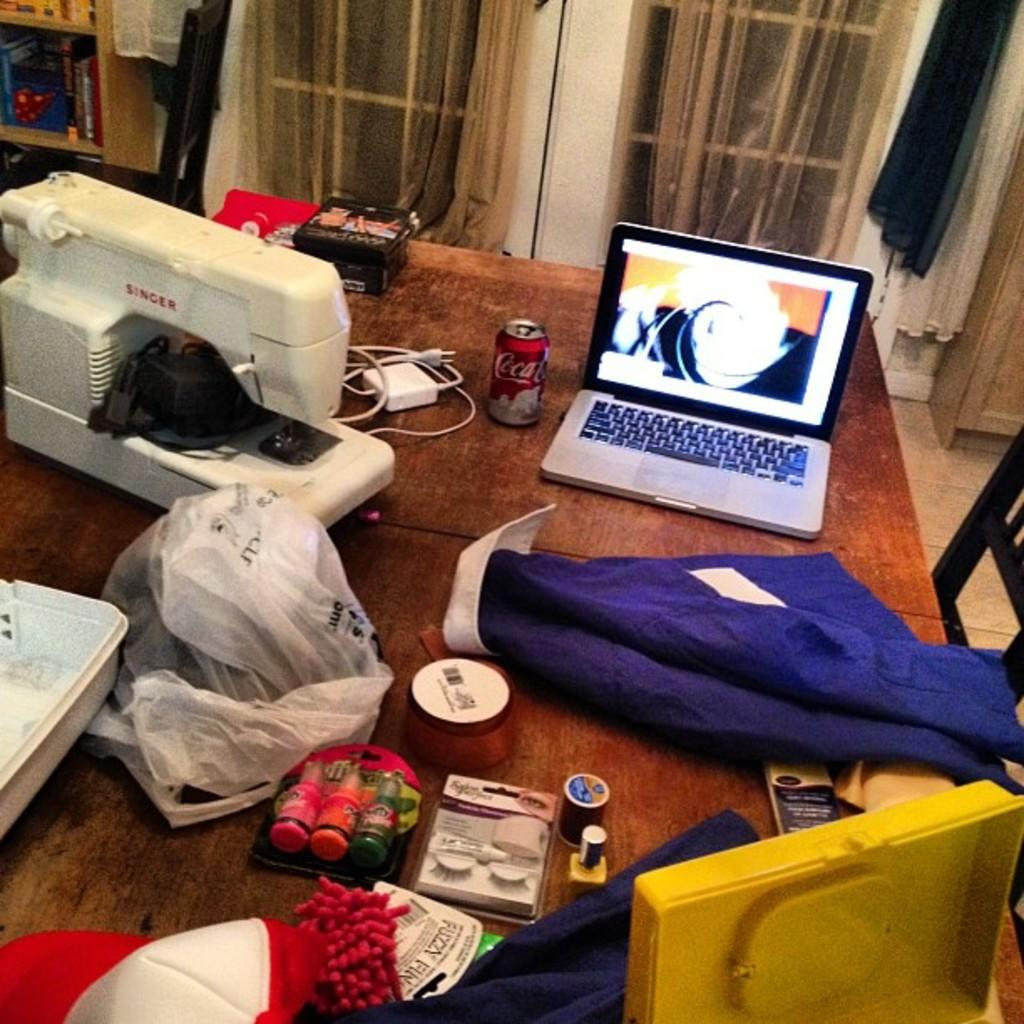What can be seen in the image that allows light and air to enter the room? There is a window in the image. What piece of furniture is present in the image that is commonly used for work or dining? There is a table in the image. What electronic device is on the table in the image? A laptop is present on the table. What other item related to sewing can be seen on the table? A sewing machine is on the table. What material is on the table that might be used for sewing or crafting? There is cloth on the table. What other electronic device is on the table in the image? A tablet is on the table. What piece of furniture is on the right side of the table in the image? There is a chair on the right side of the table. How many flowers are on the table in the image? There are no flowers present on the table in the image. What type of pencil can be seen on the table in the image? There are no pencils present on the table in the image. 